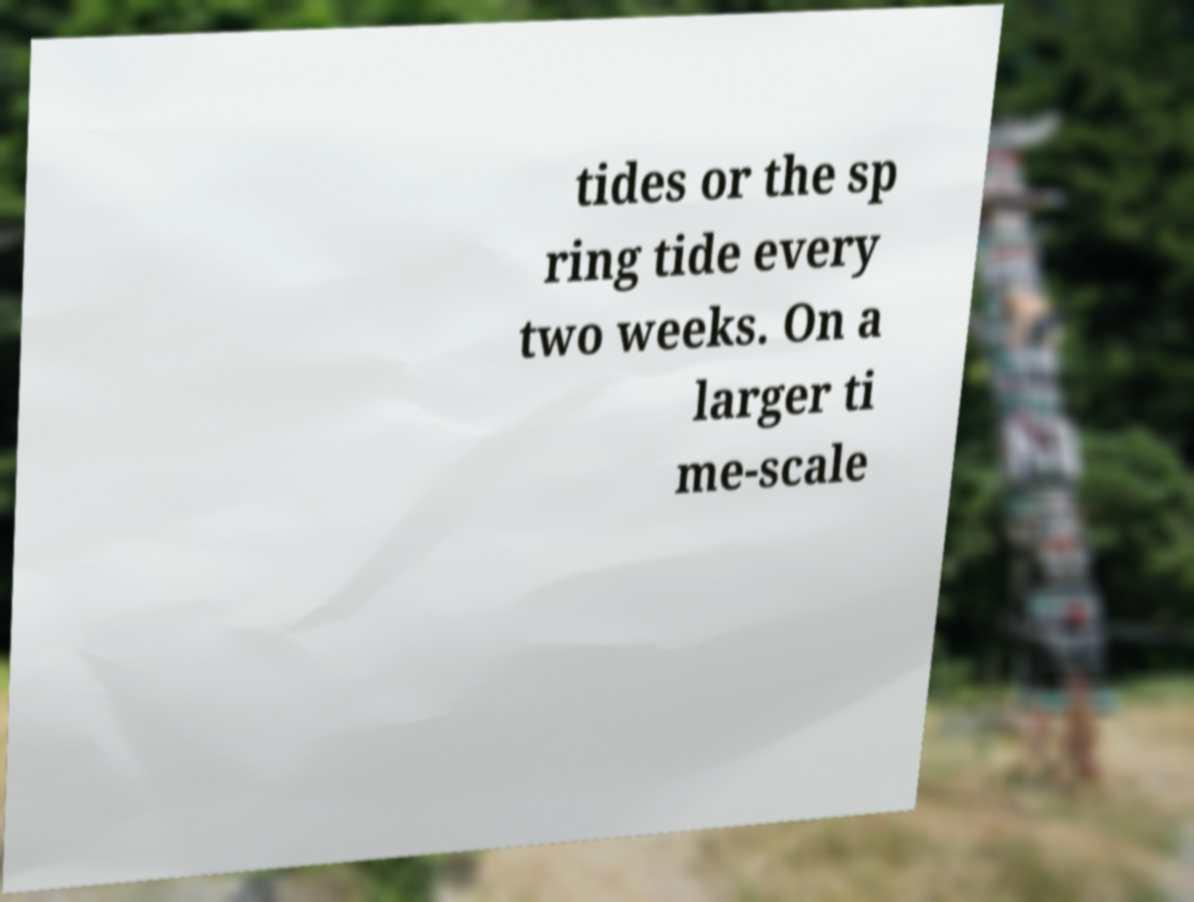What messages or text are displayed in this image? I need them in a readable, typed format. tides or the sp ring tide every two weeks. On a larger ti me-scale 